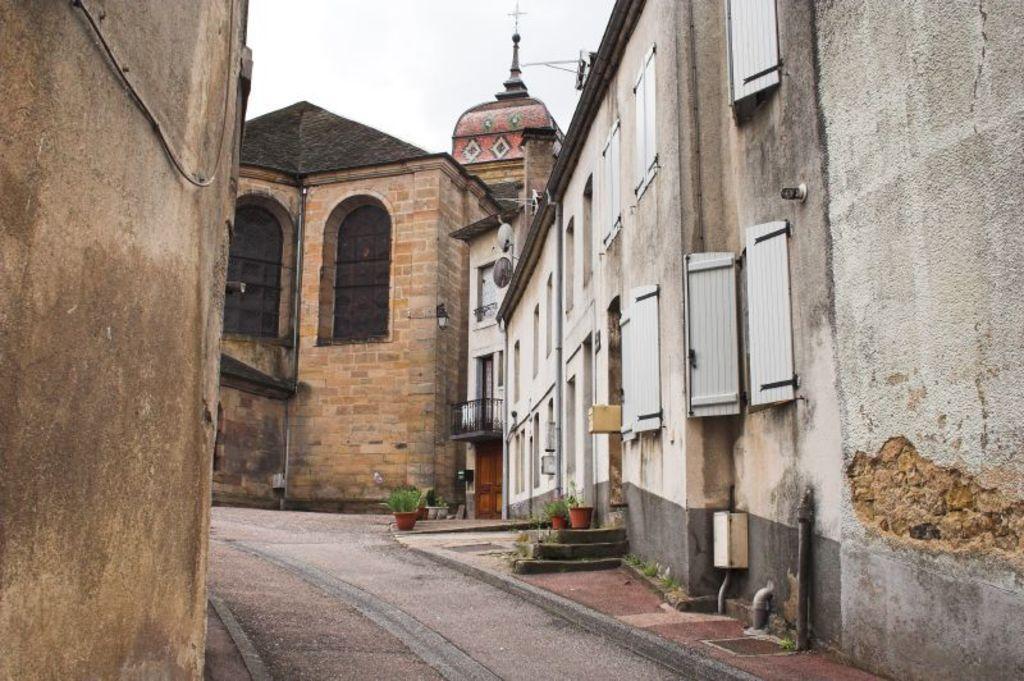Describe this image in one or two sentences. In this image we can see the buildings. At the top of the image, we can see the sky. At the bottom of the image, we can see a road, pavement and potted plants. 